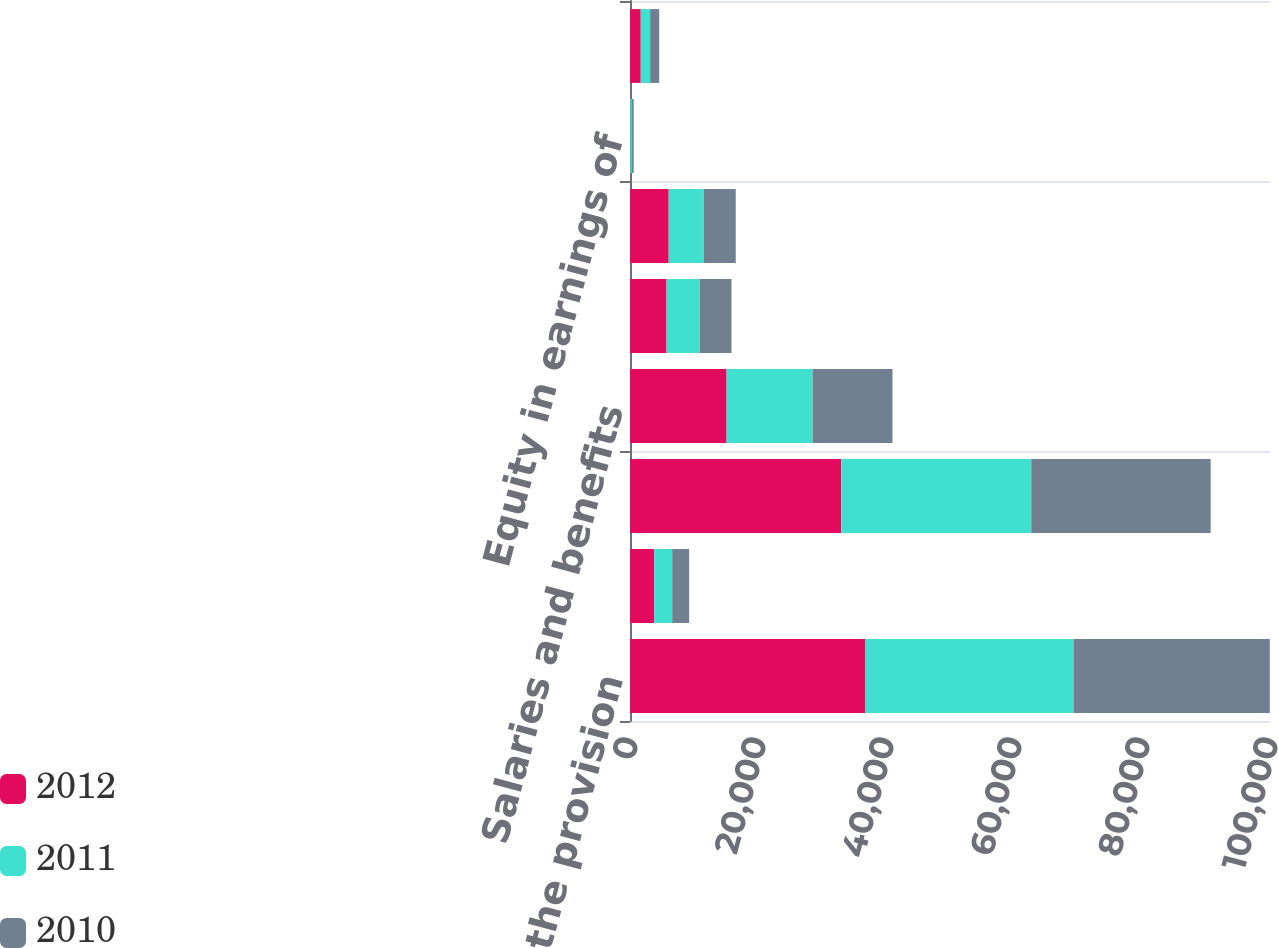Convert chart to OTSL. <chart><loc_0><loc_0><loc_500><loc_500><stacked_bar_chart><ecel><fcel>Revenues before the provision<fcel>Provision for doubtful<fcel>Revenues<fcel>Salaries and benefits<fcel>Supplies<fcel>Other operating expenses<fcel>Equity in earnings of<fcel>Depreciation and amortization<nl><fcel>2012<fcel>36783<fcel>3770<fcel>33013<fcel>15089<fcel>5717<fcel>6048<fcel>36<fcel>1679<nl><fcel>2011<fcel>32506<fcel>2824<fcel>29682<fcel>13440<fcel>5179<fcel>5470<fcel>258<fcel>1465<nl><fcel>2010<fcel>30683<fcel>2648<fcel>28035<fcel>12484<fcel>4961<fcel>5004<fcel>282<fcel>1421<nl></chart> 